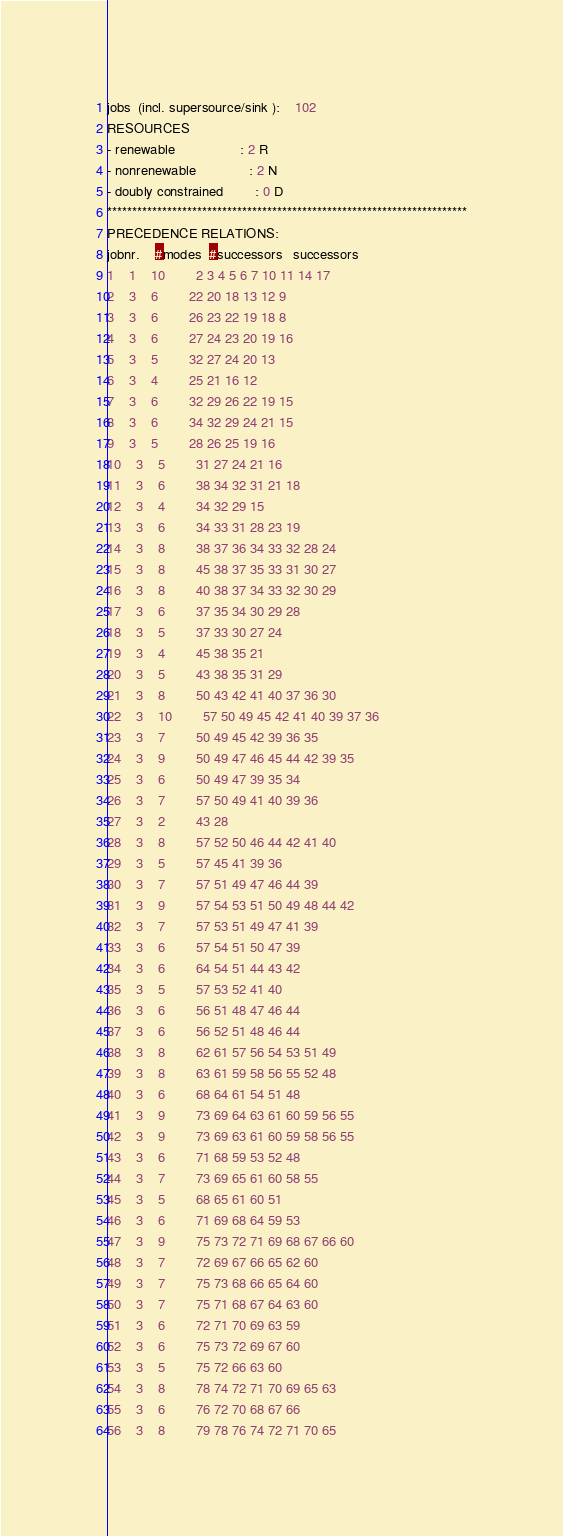Convert code to text. <code><loc_0><loc_0><loc_500><loc_500><_ObjectiveC_>jobs  (incl. supersource/sink ):	102
RESOURCES
- renewable                 : 2 R
- nonrenewable              : 2 N
- doubly constrained        : 0 D
************************************************************************
PRECEDENCE RELATIONS:
jobnr.    #modes  #successors   successors
1	1	10		2 3 4 5 6 7 10 11 14 17 
2	3	6		22 20 18 13 12 9 
3	3	6		26 23 22 19 18 8 
4	3	6		27 24 23 20 19 16 
5	3	5		32 27 24 20 13 
6	3	4		25 21 16 12 
7	3	6		32 29 26 22 19 15 
8	3	6		34 32 29 24 21 15 
9	3	5		28 26 25 19 16 
10	3	5		31 27 24 21 16 
11	3	6		38 34 32 31 21 18 
12	3	4		34 32 29 15 
13	3	6		34 33 31 28 23 19 
14	3	8		38 37 36 34 33 32 28 24 
15	3	8		45 38 37 35 33 31 30 27 
16	3	8		40 38 37 34 33 32 30 29 
17	3	6		37 35 34 30 29 28 
18	3	5		37 33 30 27 24 
19	3	4		45 38 35 21 
20	3	5		43 38 35 31 29 
21	3	8		50 43 42 41 40 37 36 30 
22	3	10		57 50 49 45 42 41 40 39 37 36 
23	3	7		50 49 45 42 39 36 35 
24	3	9		50 49 47 46 45 44 42 39 35 
25	3	6		50 49 47 39 35 34 
26	3	7		57 50 49 41 40 39 36 
27	3	2		43 28 
28	3	8		57 52 50 46 44 42 41 40 
29	3	5		57 45 41 39 36 
30	3	7		57 51 49 47 46 44 39 
31	3	9		57 54 53 51 50 49 48 44 42 
32	3	7		57 53 51 49 47 41 39 
33	3	6		57 54 51 50 47 39 
34	3	6		64 54 51 44 43 42 
35	3	5		57 53 52 41 40 
36	3	6		56 51 48 47 46 44 
37	3	6		56 52 51 48 46 44 
38	3	8		62 61 57 56 54 53 51 49 
39	3	8		63 61 59 58 56 55 52 48 
40	3	6		68 64 61 54 51 48 
41	3	9		73 69 64 63 61 60 59 56 55 
42	3	9		73 69 63 61 60 59 58 56 55 
43	3	6		71 68 59 53 52 48 
44	3	7		73 69 65 61 60 58 55 
45	3	5		68 65 61 60 51 
46	3	6		71 69 68 64 59 53 
47	3	9		75 73 72 71 69 68 67 66 60 
48	3	7		72 69 67 66 65 62 60 
49	3	7		75 73 68 66 65 64 60 
50	3	7		75 71 68 67 64 63 60 
51	3	6		72 71 70 69 63 59 
52	3	6		75 73 72 69 67 60 
53	3	5		75 72 66 63 60 
54	3	8		78 74 72 71 70 69 65 63 
55	3	6		76 72 70 68 67 66 
56	3	8		79 78 76 74 72 71 70 65 </code> 